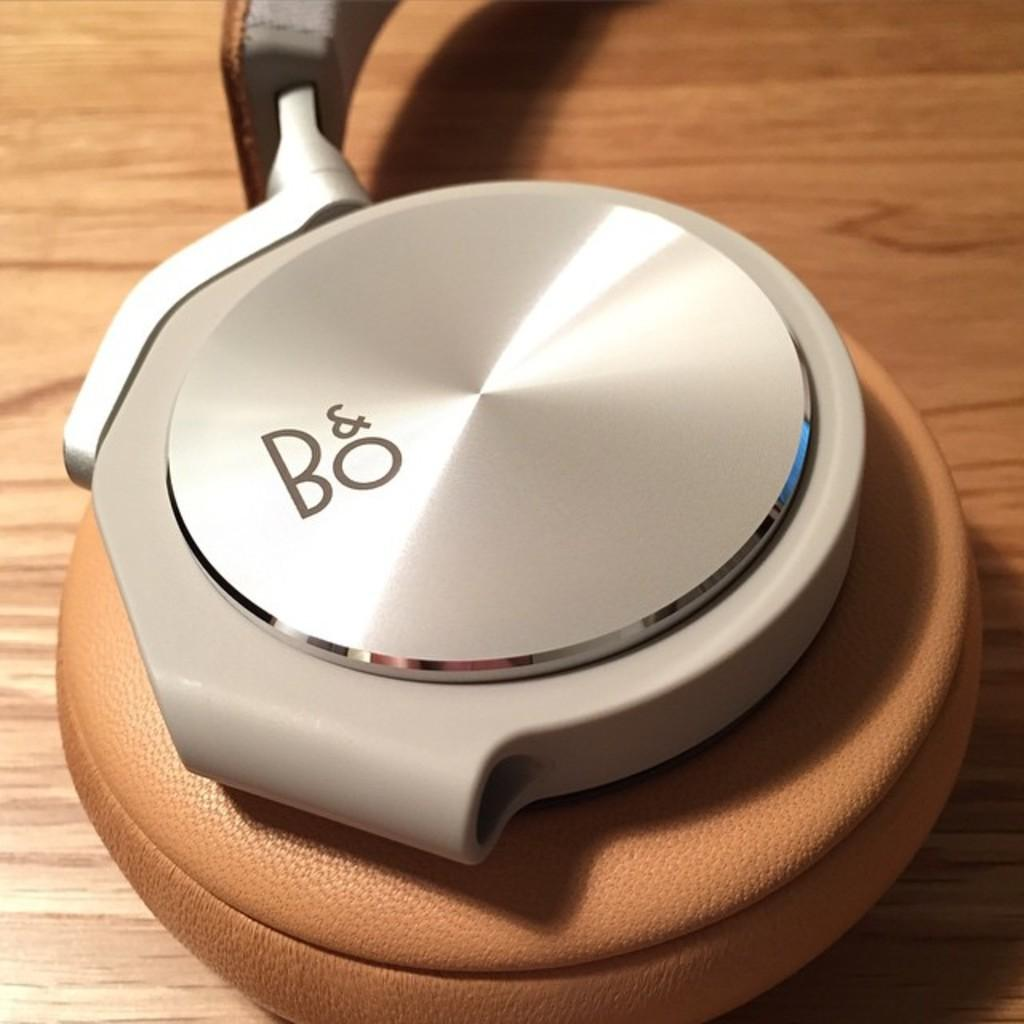Provide a one-sentence caption for the provided image. A pair of tan headphones that say B&O on the ear piece. 